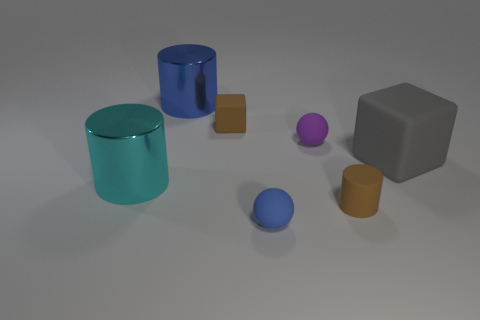Subtract all big cylinders. How many cylinders are left? 1 Add 1 tiny purple matte objects. How many objects exist? 8 Subtract all brown cylinders. How many cylinders are left? 2 Subtract 3 cylinders. How many cylinders are left? 0 Subtract all cyan spheres. How many green cylinders are left? 0 Subtract all purple matte things. Subtract all brown cubes. How many objects are left? 5 Add 2 blue things. How many blue things are left? 4 Add 5 cyan cylinders. How many cyan cylinders exist? 6 Subtract 1 blue balls. How many objects are left? 6 Subtract all balls. How many objects are left? 5 